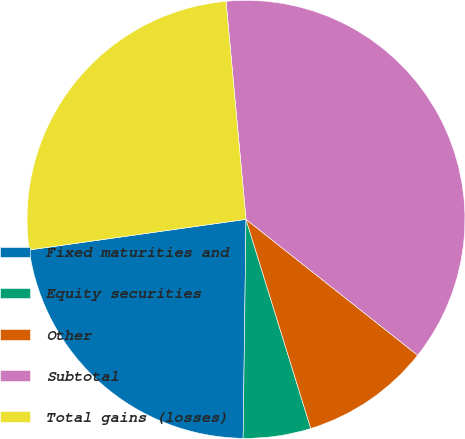Convert chart. <chart><loc_0><loc_0><loc_500><loc_500><pie_chart><fcel>Fixed maturities and<fcel>Equity securities<fcel>Other<fcel>Subtotal<fcel>Total gains (losses)<nl><fcel>22.56%<fcel>4.99%<fcel>9.56%<fcel>37.11%<fcel>25.78%<nl></chart> 